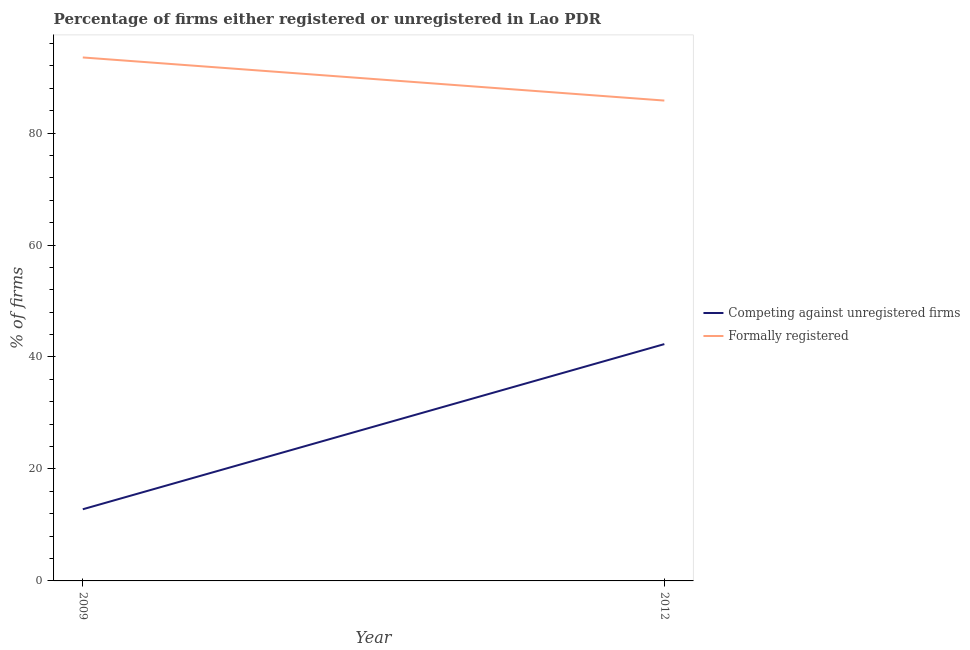How many different coloured lines are there?
Offer a terse response. 2. Is the number of lines equal to the number of legend labels?
Your answer should be very brief. Yes. What is the percentage of formally registered firms in 2009?
Your answer should be very brief. 93.5. Across all years, what is the maximum percentage of formally registered firms?
Give a very brief answer. 93.5. In which year was the percentage of registered firms minimum?
Make the answer very short. 2009. What is the total percentage of registered firms in the graph?
Provide a short and direct response. 55.1. What is the difference between the percentage of registered firms in 2009 and that in 2012?
Make the answer very short. -29.5. What is the difference between the percentage of formally registered firms in 2009 and the percentage of registered firms in 2012?
Your answer should be very brief. 51.2. What is the average percentage of formally registered firms per year?
Ensure brevity in your answer.  89.65. In the year 2012, what is the difference between the percentage of formally registered firms and percentage of registered firms?
Your response must be concise. 43.5. In how many years, is the percentage of registered firms greater than 72 %?
Offer a terse response. 0. What is the ratio of the percentage of registered firms in 2009 to that in 2012?
Provide a short and direct response. 0.3. In how many years, is the percentage of formally registered firms greater than the average percentage of formally registered firms taken over all years?
Give a very brief answer. 1. Does the graph contain any zero values?
Offer a terse response. No. How are the legend labels stacked?
Make the answer very short. Vertical. What is the title of the graph?
Make the answer very short. Percentage of firms either registered or unregistered in Lao PDR. Does "IMF nonconcessional" appear as one of the legend labels in the graph?
Your answer should be very brief. No. What is the label or title of the X-axis?
Offer a very short reply. Year. What is the label or title of the Y-axis?
Make the answer very short. % of firms. What is the % of firms of Competing against unregistered firms in 2009?
Provide a short and direct response. 12.8. What is the % of firms of Formally registered in 2009?
Your response must be concise. 93.5. What is the % of firms in Competing against unregistered firms in 2012?
Your answer should be compact. 42.3. What is the % of firms of Formally registered in 2012?
Ensure brevity in your answer.  85.8. Across all years, what is the maximum % of firms in Competing against unregistered firms?
Offer a terse response. 42.3. Across all years, what is the maximum % of firms in Formally registered?
Provide a short and direct response. 93.5. Across all years, what is the minimum % of firms in Competing against unregistered firms?
Offer a very short reply. 12.8. Across all years, what is the minimum % of firms of Formally registered?
Offer a terse response. 85.8. What is the total % of firms in Competing against unregistered firms in the graph?
Give a very brief answer. 55.1. What is the total % of firms of Formally registered in the graph?
Offer a terse response. 179.3. What is the difference between the % of firms in Competing against unregistered firms in 2009 and that in 2012?
Ensure brevity in your answer.  -29.5. What is the difference between the % of firms in Formally registered in 2009 and that in 2012?
Give a very brief answer. 7.7. What is the difference between the % of firms in Competing against unregistered firms in 2009 and the % of firms in Formally registered in 2012?
Your answer should be very brief. -73. What is the average % of firms of Competing against unregistered firms per year?
Offer a terse response. 27.55. What is the average % of firms of Formally registered per year?
Offer a terse response. 89.65. In the year 2009, what is the difference between the % of firms of Competing against unregistered firms and % of firms of Formally registered?
Offer a very short reply. -80.7. In the year 2012, what is the difference between the % of firms in Competing against unregistered firms and % of firms in Formally registered?
Your answer should be very brief. -43.5. What is the ratio of the % of firms in Competing against unregistered firms in 2009 to that in 2012?
Provide a short and direct response. 0.3. What is the ratio of the % of firms of Formally registered in 2009 to that in 2012?
Your answer should be very brief. 1.09. What is the difference between the highest and the second highest % of firms in Competing against unregistered firms?
Provide a succinct answer. 29.5. What is the difference between the highest and the lowest % of firms of Competing against unregistered firms?
Make the answer very short. 29.5. What is the difference between the highest and the lowest % of firms of Formally registered?
Ensure brevity in your answer.  7.7. 